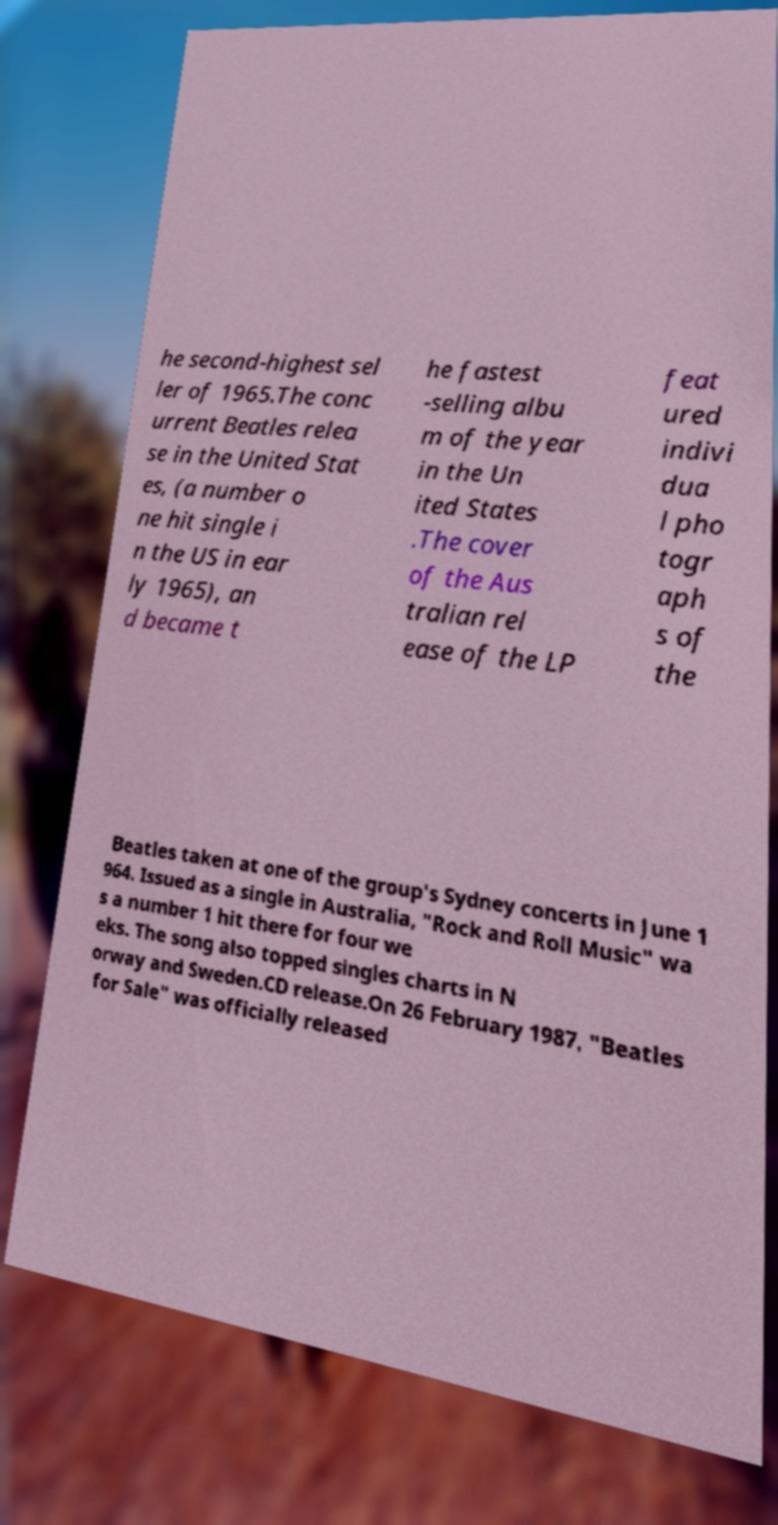Can you read and provide the text displayed in the image?This photo seems to have some interesting text. Can you extract and type it out for me? he second-highest sel ler of 1965.The conc urrent Beatles relea se in the United Stat es, (a number o ne hit single i n the US in ear ly 1965), an d became t he fastest -selling albu m of the year in the Un ited States .The cover of the Aus tralian rel ease of the LP feat ured indivi dua l pho togr aph s of the Beatles taken at one of the group's Sydney concerts in June 1 964. Issued as a single in Australia, "Rock and Roll Music" wa s a number 1 hit there for four we eks. The song also topped singles charts in N orway and Sweden.CD release.On 26 February 1987, "Beatles for Sale" was officially released 